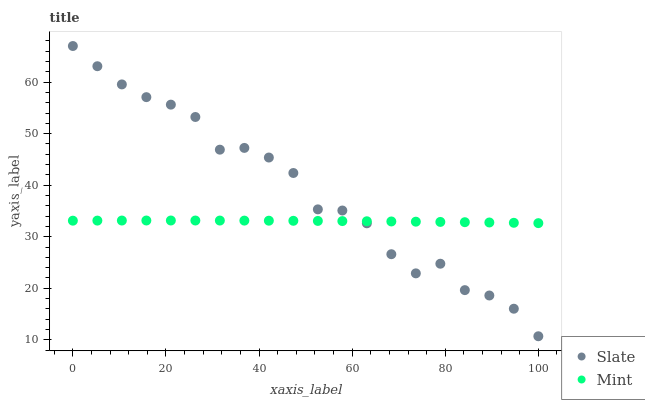Does Mint have the minimum area under the curve?
Answer yes or no. Yes. Does Slate have the maximum area under the curve?
Answer yes or no. Yes. Does Mint have the maximum area under the curve?
Answer yes or no. No. Is Mint the smoothest?
Answer yes or no. Yes. Is Slate the roughest?
Answer yes or no. Yes. Is Mint the roughest?
Answer yes or no. No. Does Slate have the lowest value?
Answer yes or no. Yes. Does Mint have the lowest value?
Answer yes or no. No. Does Slate have the highest value?
Answer yes or no. Yes. Does Mint have the highest value?
Answer yes or no. No. Does Mint intersect Slate?
Answer yes or no. Yes. Is Mint less than Slate?
Answer yes or no. No. Is Mint greater than Slate?
Answer yes or no. No. 